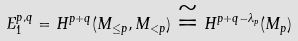<formula> <loc_0><loc_0><loc_500><loc_500>E _ { 1 } ^ { p , q } = H ^ { p + q } ( M _ { \leq p } , M _ { < p } ) \cong H ^ { p + q - \lambda _ { p } } ( M _ { p } )</formula> 